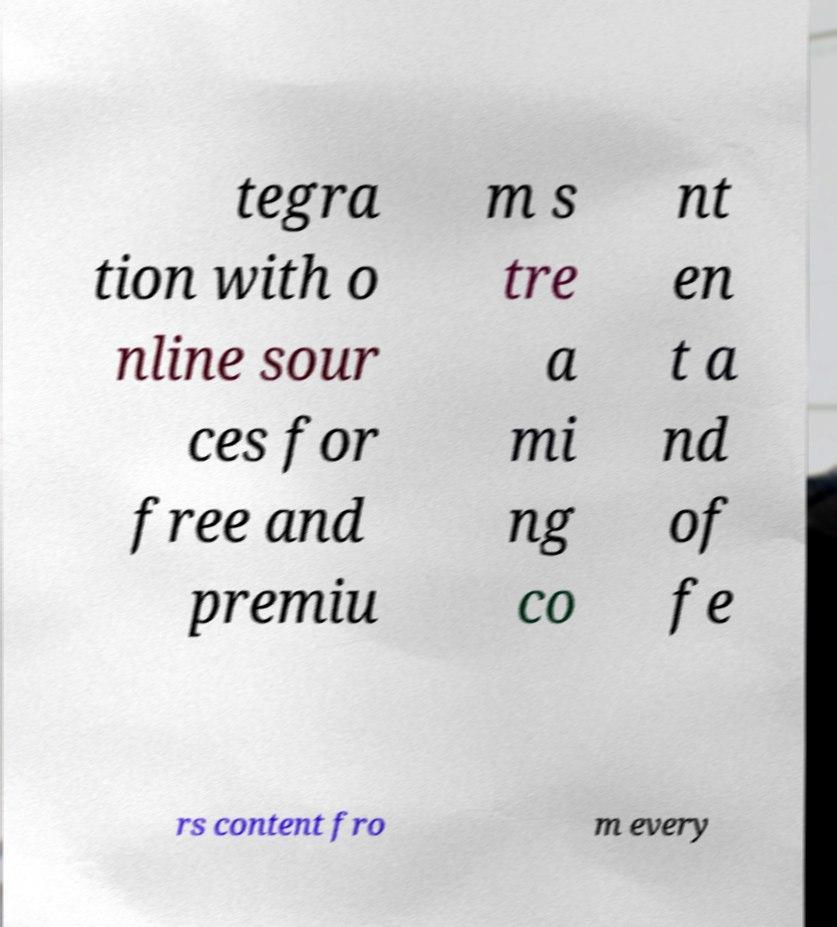Can you accurately transcribe the text from the provided image for me? tegra tion with o nline sour ces for free and premiu m s tre a mi ng co nt en t a nd of fe rs content fro m every 